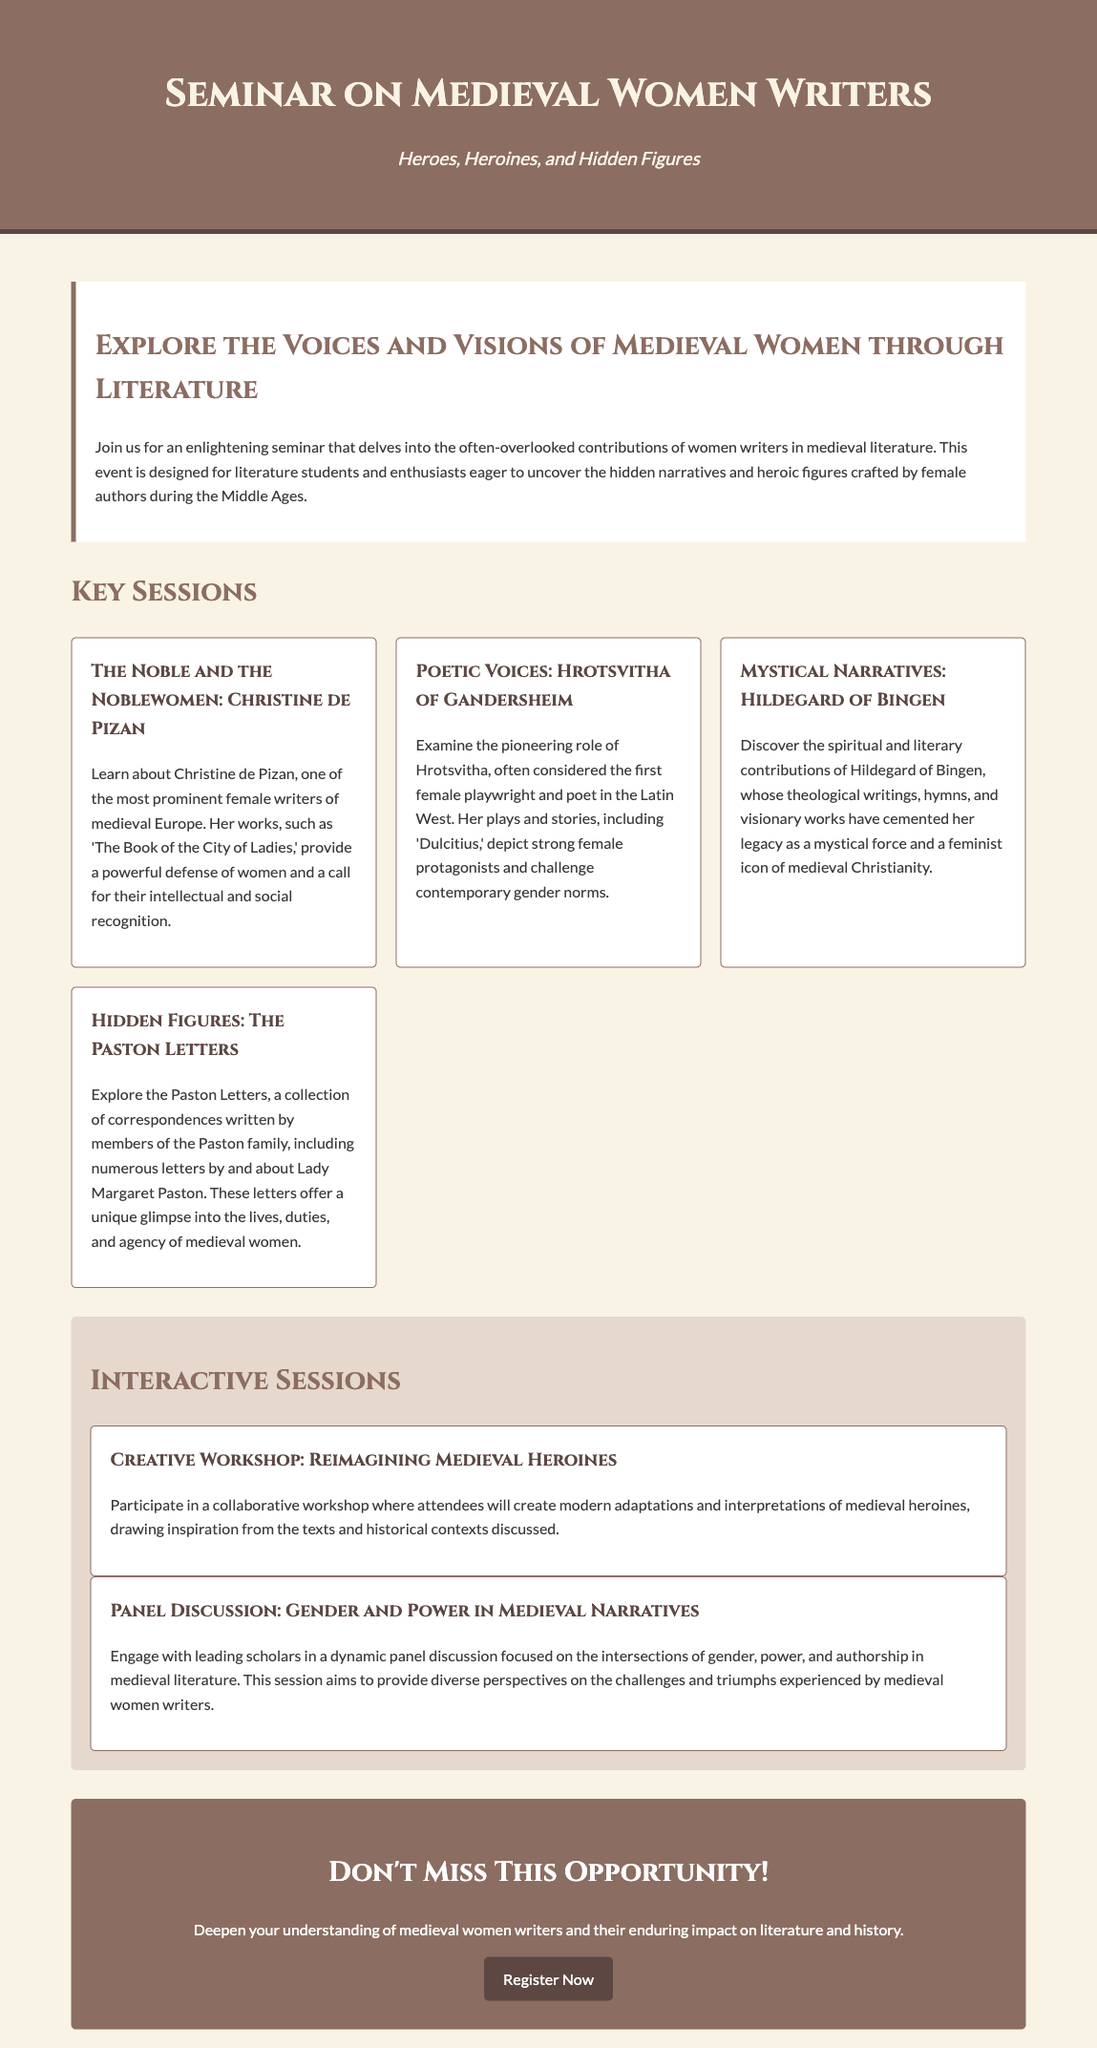What is the title of the seminar? The title is prominently displayed at the top of the document.
Answer: Seminar on Medieval Women Writers Who is a featured writer discussed in the seminar sessions? The document lists sessions that highlight specific women writers, such as Christine de Pizan.
Answer: Christine de Pizan What is the focus of the interactive session on gender? This interactive session aims to explore issues related to gender and power through literature.
Answer: Gender and Power in Medieval Narratives How many key sessions are outlined in the document? The number of key sessions is explicit in the structure of the document.
Answer: Four Who is known as the first female playwright in the Latin West? The document provides specific information about significant female writers in medieval literature.
Answer: Hrotsvitha of Gandersheim What type of workshop is included in the interactive sessions? The type of workshop is mentioned in the section dedicated to interactive elements of the seminar.
Answer: Creative Workshop: Reimagining Medieval Heroines What is the date or time of the seminar mentioned in the document? The document does not specify a date or time, indicating the event details are not listed.
Answer: Not specified What is the main theme of the seminar? The theme is highlighted in the subtitle and introductory paragraph of the document.
Answer: Heroes, Heroines, and Hidden Figures 